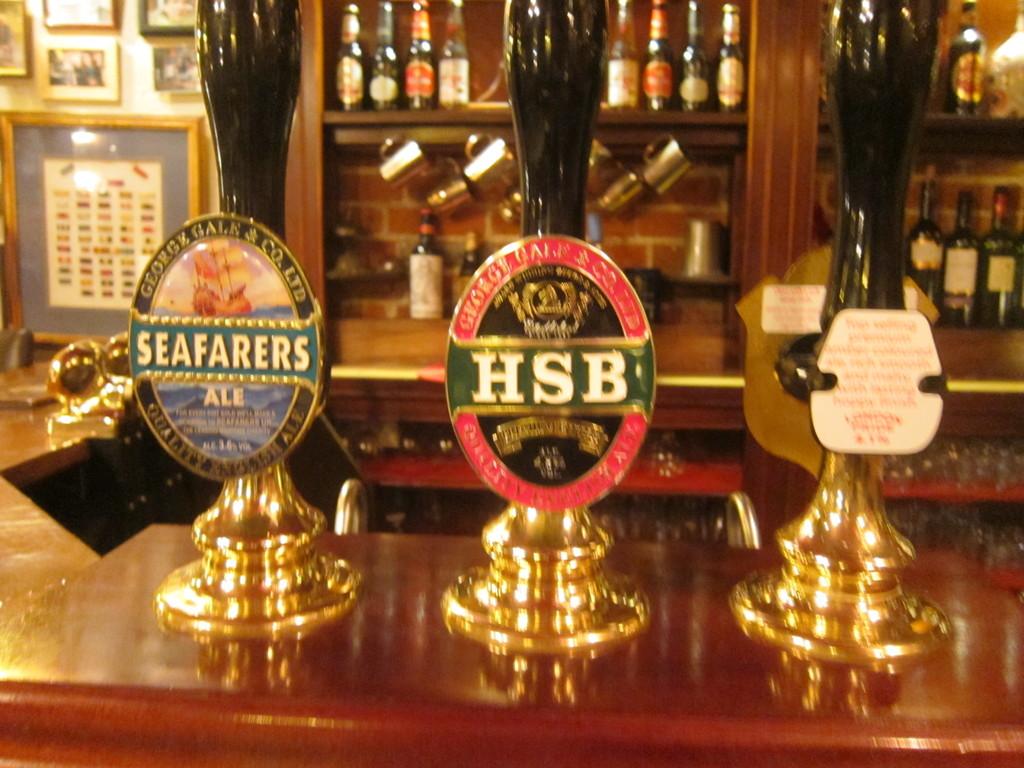Which is the left tap?
Give a very brief answer. Seafarers. What is served from the middle tap?
Ensure brevity in your answer.  Hsb. 